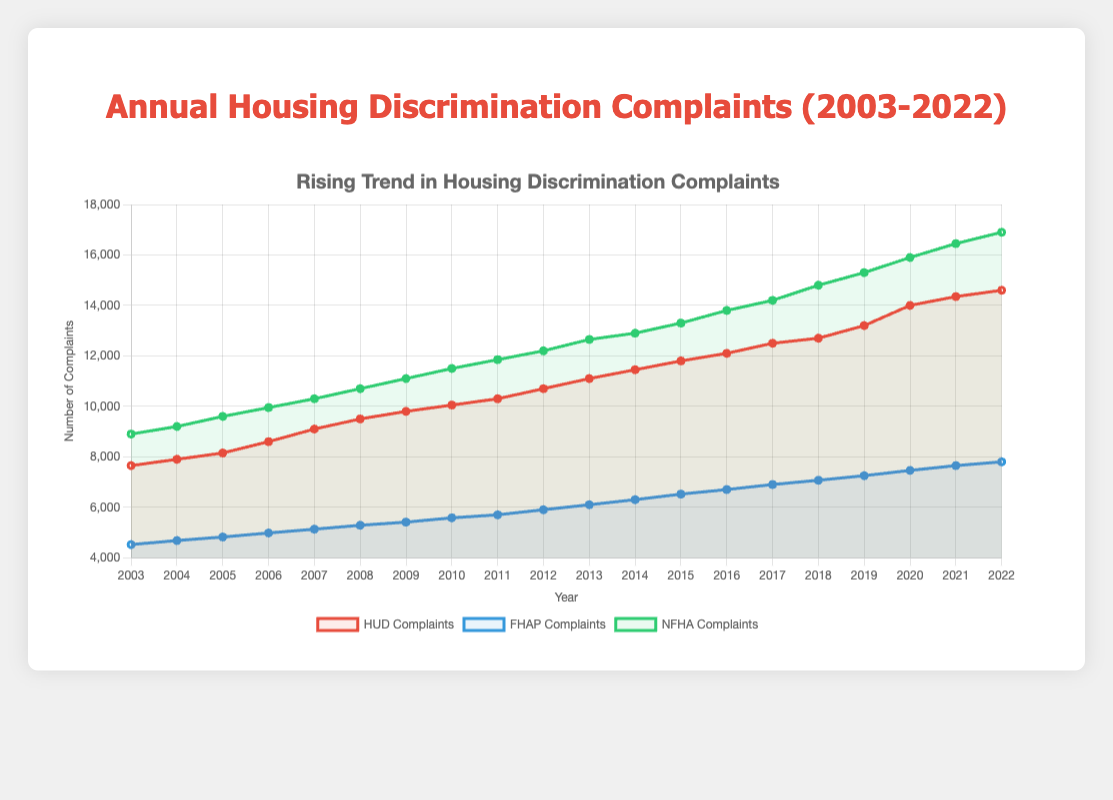What trends are observable in the number of HUD complaints over the years? The number of HUD complaints has been steadily increasing from around 7650 in 2003 to approximately 14600 in 2022, indicating a continuous rise over the 20-year period.
Answer: Steadily increasing Which year had the highest number of FHAP complaints? By examining the chart, the year with the highest number of FHAP complaints is 2022, with around 7800 complaints.
Answer: 2022 How does the number of HUD complaints in 2022 compare to NFHA complaints in the same year? The number of HUD complaints in 2022 is about 14600, while NFHA complaints are approximately 16900. This shows that there are more NFHA complaints than HUD complaints in 2022.
Answer: More NFHA complaints What is the total number of complaints filed (HUD, FHAP, and NFHA) in 2010? To get the total number of complaints in 2010, sum the complaints from HUD (10050), FHAP (5580), and NFHA (11500). Therefore, 10050 + 5580 + 11500 = 27130.
Answer: 27130 Which category of complaints showed the highest increase from 2003 to 2022? From the chart, NFHA complaints rose from 8900 in 2003 to 16900 in 2022, an increase of 8000. Neither HUD (7650 to 14600) nor FHAP (4520 to 7800) increased by as much.
Answer: NFHA complaints What color represents the NFHA complaints in the chart? The NFHA complaints are represented by a green line on the chart.
Answer: Green What is the difference in the number of HUD vs. FHAP complaints in 2008? For 2008, HUD complaints are 9500, and FHAP complaints are 5285. The difference is 9500 - 5285 = 4215.
Answer: 4215 How does the trend of FHAP complaints from 2003 to 2022 compare with HUD complaints? Both HUD and FHAP complaints show an increasing trend from 2003 to 2022, but the absolute numbers for HUD complaints are consistently higher than FHAP complaints throughout the period.
Answer: Both increased, HUD higher What is the average annual increase in NFHA complaints from 2003 to 2022? The total increase in NFHA complaints from 2003 (8900) to 2022 (16900) is 16900 - 8900 = 8000. Over 19 years (2022-2003), the average annual increase is 8000 / 19 ≈ 421.
Answer: ~421 Between which consecutive years did HUD complaints see the largest increase? HUD complaints increased most significantly between 2019 (13200) and 2020 (14000), with an increase of 14000 - 13200 = 800 complaints.
Answer: 2019-2020 